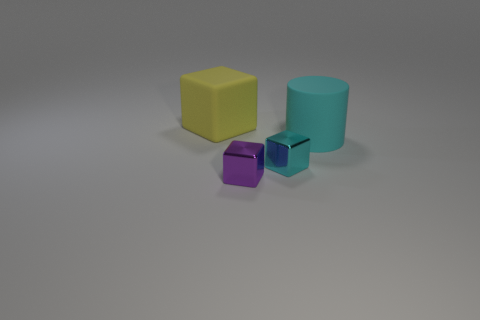Add 4 big red matte cubes. How many objects exist? 8 Subtract all cylinders. How many objects are left? 3 Add 2 big yellow blocks. How many big yellow blocks exist? 3 Subtract 0 blue spheres. How many objects are left? 4 Subtract all large yellow shiny cylinders. Subtract all rubber blocks. How many objects are left? 3 Add 1 matte cylinders. How many matte cylinders are left? 2 